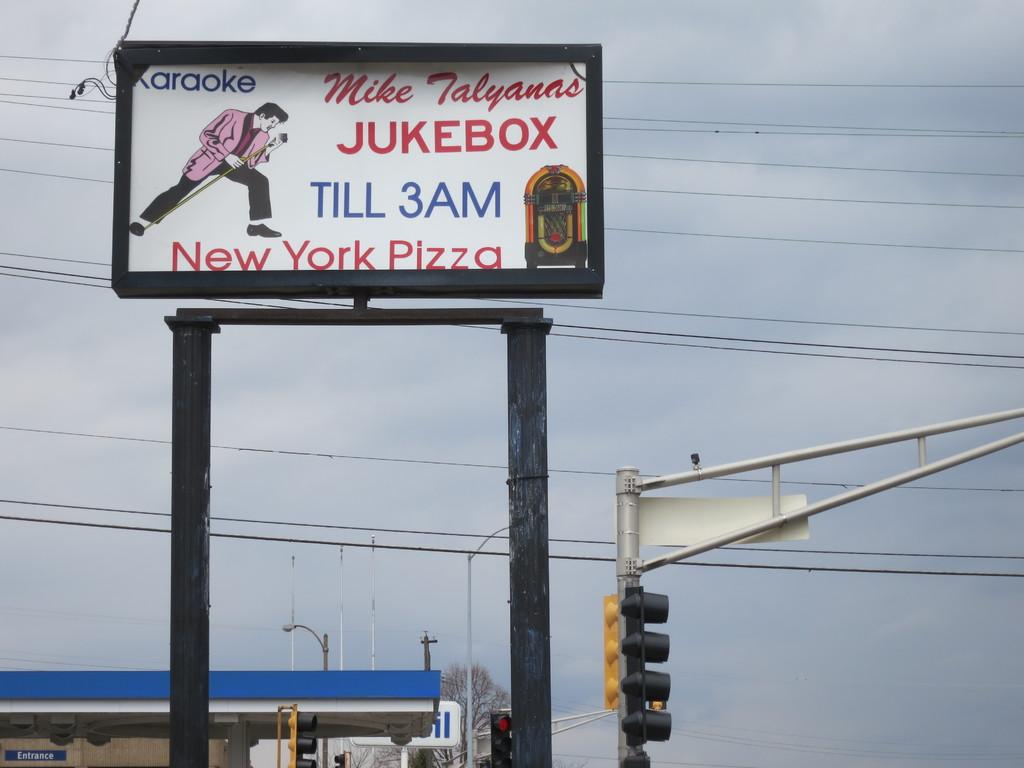<image>
Render a clear and concise summary of the photo. A large sign above a traffic light says Jukebox Till 3AM. 